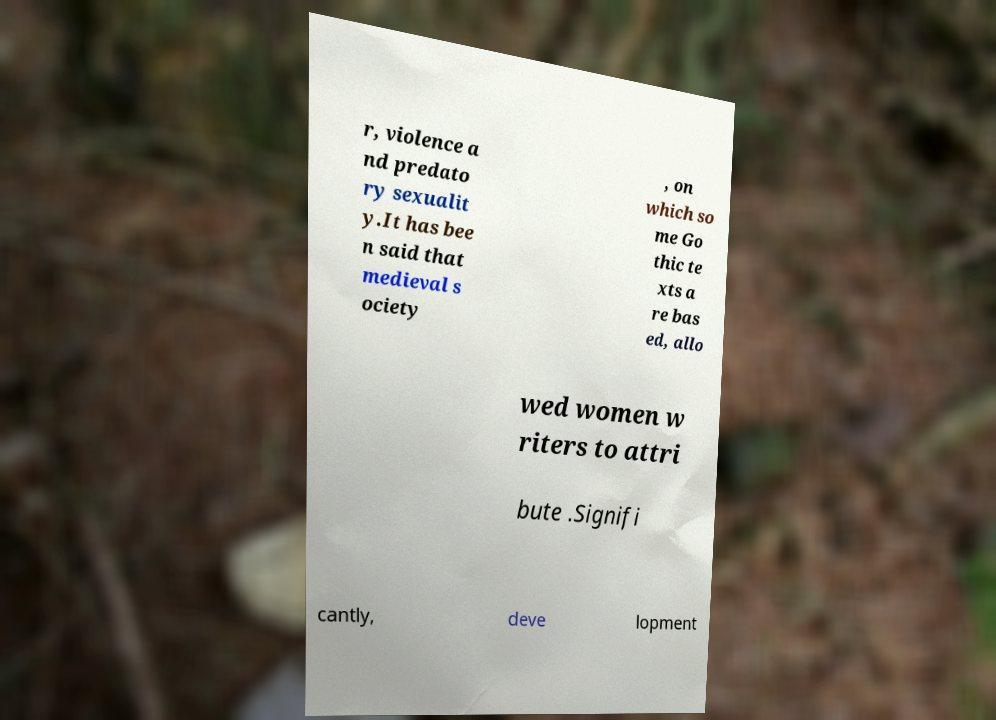Could you extract and type out the text from this image? r, violence a nd predato ry sexualit y.It has bee n said that medieval s ociety , on which so me Go thic te xts a re bas ed, allo wed women w riters to attri bute .Signifi cantly, deve lopment 